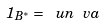<formula> <loc_0><loc_0><loc_500><loc_500>1 _ { B ^ { * } } = \ u n { \ v a }</formula> 